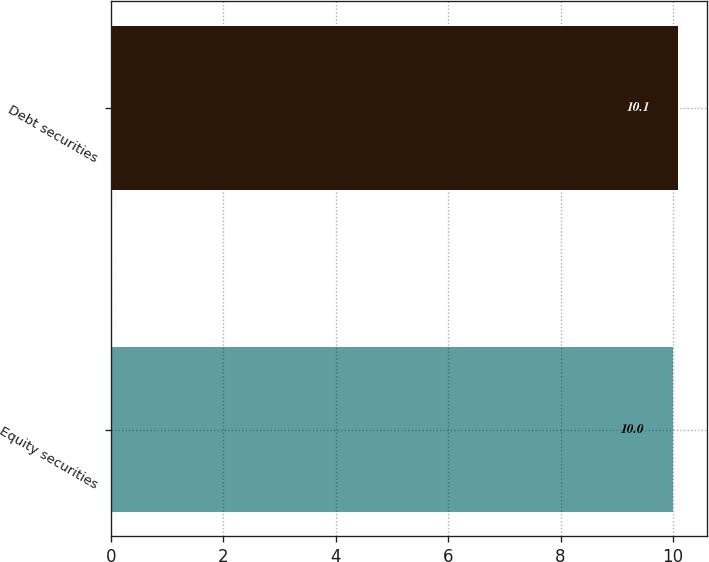Convert chart. <chart><loc_0><loc_0><loc_500><loc_500><bar_chart><fcel>Equity securities<fcel>Debt securities<nl><fcel>10<fcel>10.1<nl></chart> 